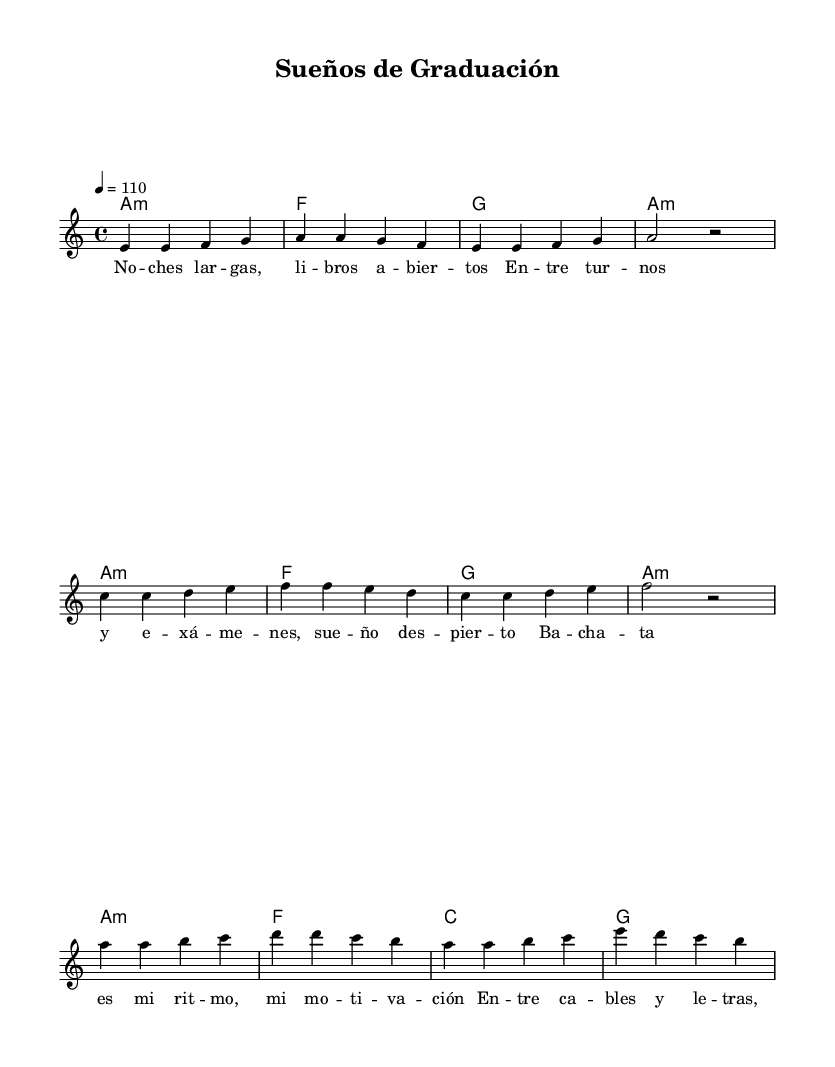What is the key signature of this music? The key signature is determined by the key specified at the start of the score. In this case, it indicates "a minor," which has no sharps or flats.
Answer: a minor What is the time signature of this piece? The time signature is shown at the beginning of the score, represented as "4/4." This indicates there are four beats in each measure.
Answer: 4/4 What is the tempo marking of the piece? The tempo marking is typically indicated at the beginning, showing the speed of the piece. Here, it says "4 = 110," meaning there are 110 beats per minute.
Answer: 110 How many measures are in the intro section? The intro section is defined in the sheet music and consists of four measures in total. Each measure is separated by a vertical line.
Answer: 4 What is the main theme conveyed in the chorus lyrics? The chorus lyrics highlight the artist's motivation linked to pursuing graduation amidst challenges. The main theme revolves around musical rhythm and aspirations for education.
Answer: Motivation What type of musical form does this piece primarily follow? The piece includes a repeating structure of verses followed by a chorus, which suggests a common song format. In this case, it displays a verse-chorus structure typical of many Latin songs.
Answer: Verse-Chorus What instruments are indicated for performance in this score? The score specifies a vocal melody and chord names, suggesting it is primarily intended for voice accompanied by harmonic chords, typical for Bachata. There are no additional instrument notations.
Answer: Voice and Chords 